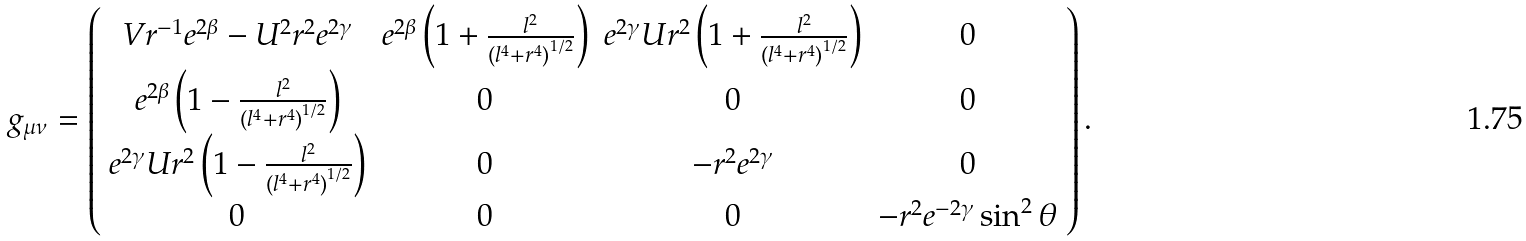<formula> <loc_0><loc_0><loc_500><loc_500>g _ { \mu \nu } = \left ( \begin{array} { c c c c } V r ^ { - 1 } e ^ { 2 \beta } - U ^ { 2 } r ^ { 2 } e ^ { 2 \gamma } & e ^ { 2 \beta } \left ( 1 + \frac { l ^ { 2 } } { { ( l ^ { 4 } + r ^ { 4 } ) } ^ { 1 / 2 } } \right ) & e ^ { 2 \gamma } U r ^ { 2 } \left ( 1 + \frac { l ^ { 2 } } { { ( l ^ { 4 } + r ^ { 4 } ) } ^ { 1 / 2 } } \right ) & 0 \\ e ^ { 2 \beta } \left ( 1 - \frac { l ^ { 2 } } { { ( l ^ { 4 } + r ^ { 4 } ) } ^ { 1 / 2 } } \right ) & 0 & 0 & 0 \\ e ^ { 2 \gamma } U r ^ { 2 } \left ( 1 - \frac { l ^ { 2 } } { { ( l ^ { 4 } + r ^ { 4 } ) } ^ { 1 / 2 } } \right ) & 0 & - r ^ { 2 } e ^ { 2 \gamma } & 0 \\ 0 & 0 & 0 & - r ^ { 2 } e ^ { - 2 \gamma } \sin ^ { 2 } \theta \end{array} \right ) .</formula> 